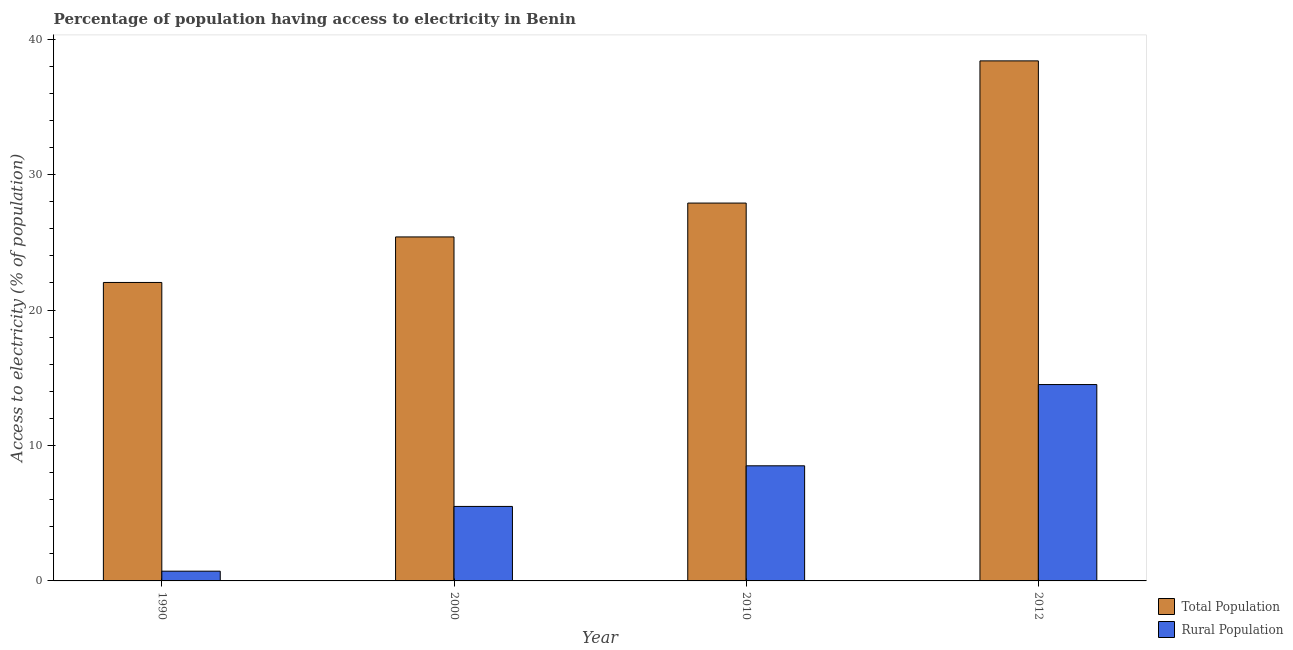How many different coloured bars are there?
Provide a short and direct response. 2. How many groups of bars are there?
Your response must be concise. 4. Are the number of bars per tick equal to the number of legend labels?
Provide a short and direct response. Yes. How many bars are there on the 1st tick from the left?
Offer a terse response. 2. How many bars are there on the 2nd tick from the right?
Ensure brevity in your answer.  2. Across all years, what is the maximum percentage of rural population having access to electricity?
Offer a terse response. 14.5. Across all years, what is the minimum percentage of rural population having access to electricity?
Offer a terse response. 0.72. In which year was the percentage of rural population having access to electricity maximum?
Offer a very short reply. 2012. What is the total percentage of population having access to electricity in the graph?
Offer a terse response. 113.74. What is the difference between the percentage of population having access to electricity in 1990 and that in 2010?
Offer a terse response. -5.86. What is the average percentage of rural population having access to electricity per year?
Your answer should be compact. 7.3. What is the ratio of the percentage of population having access to electricity in 1990 to that in 2000?
Provide a succinct answer. 0.87. What is the difference between the highest and the second highest percentage of rural population having access to electricity?
Provide a short and direct response. 6. What is the difference between the highest and the lowest percentage of population having access to electricity?
Your response must be concise. 16.36. Is the sum of the percentage of rural population having access to electricity in 2000 and 2012 greater than the maximum percentage of population having access to electricity across all years?
Your response must be concise. Yes. What does the 1st bar from the left in 2010 represents?
Your answer should be very brief. Total Population. What does the 1st bar from the right in 2000 represents?
Your answer should be compact. Rural Population. Are all the bars in the graph horizontal?
Your response must be concise. No. How many years are there in the graph?
Your response must be concise. 4. Are the values on the major ticks of Y-axis written in scientific E-notation?
Provide a short and direct response. No. Does the graph contain any zero values?
Make the answer very short. No. Does the graph contain grids?
Offer a terse response. No. Where does the legend appear in the graph?
Your response must be concise. Bottom right. What is the title of the graph?
Provide a short and direct response. Percentage of population having access to electricity in Benin. Does "Arms imports" appear as one of the legend labels in the graph?
Give a very brief answer. No. What is the label or title of the X-axis?
Give a very brief answer. Year. What is the label or title of the Y-axis?
Your answer should be very brief. Access to electricity (% of population). What is the Access to electricity (% of population) of Total Population in 1990?
Ensure brevity in your answer.  22.04. What is the Access to electricity (% of population) in Rural Population in 1990?
Ensure brevity in your answer.  0.72. What is the Access to electricity (% of population) in Total Population in 2000?
Provide a succinct answer. 25.4. What is the Access to electricity (% of population) of Total Population in 2010?
Give a very brief answer. 27.9. What is the Access to electricity (% of population) of Total Population in 2012?
Provide a succinct answer. 38.4. What is the Access to electricity (% of population) in Rural Population in 2012?
Ensure brevity in your answer.  14.5. Across all years, what is the maximum Access to electricity (% of population) in Total Population?
Make the answer very short. 38.4. Across all years, what is the minimum Access to electricity (% of population) in Total Population?
Provide a short and direct response. 22.04. Across all years, what is the minimum Access to electricity (% of population) of Rural Population?
Provide a succinct answer. 0.72. What is the total Access to electricity (% of population) of Total Population in the graph?
Give a very brief answer. 113.74. What is the total Access to electricity (% of population) of Rural Population in the graph?
Offer a terse response. 29.22. What is the difference between the Access to electricity (% of population) of Total Population in 1990 and that in 2000?
Make the answer very short. -3.36. What is the difference between the Access to electricity (% of population) in Rural Population in 1990 and that in 2000?
Provide a succinct answer. -4.78. What is the difference between the Access to electricity (% of population) of Total Population in 1990 and that in 2010?
Keep it short and to the point. -5.86. What is the difference between the Access to electricity (% of population) in Rural Population in 1990 and that in 2010?
Offer a terse response. -7.78. What is the difference between the Access to electricity (% of population) in Total Population in 1990 and that in 2012?
Provide a short and direct response. -16.36. What is the difference between the Access to electricity (% of population) of Rural Population in 1990 and that in 2012?
Give a very brief answer. -13.78. What is the difference between the Access to electricity (% of population) in Rural Population in 2000 and that in 2010?
Make the answer very short. -3. What is the difference between the Access to electricity (% of population) in Rural Population in 2000 and that in 2012?
Your response must be concise. -9. What is the difference between the Access to electricity (% of population) in Total Population in 2010 and that in 2012?
Give a very brief answer. -10.5. What is the difference between the Access to electricity (% of population) in Total Population in 1990 and the Access to electricity (% of population) in Rural Population in 2000?
Your response must be concise. 16.54. What is the difference between the Access to electricity (% of population) of Total Population in 1990 and the Access to electricity (% of population) of Rural Population in 2010?
Provide a short and direct response. 13.54. What is the difference between the Access to electricity (% of population) of Total Population in 1990 and the Access to electricity (% of population) of Rural Population in 2012?
Offer a terse response. 7.54. What is the difference between the Access to electricity (% of population) in Total Population in 2000 and the Access to electricity (% of population) in Rural Population in 2010?
Ensure brevity in your answer.  16.9. What is the difference between the Access to electricity (% of population) of Total Population in 2000 and the Access to electricity (% of population) of Rural Population in 2012?
Provide a short and direct response. 10.9. What is the average Access to electricity (% of population) in Total Population per year?
Your response must be concise. 28.43. What is the average Access to electricity (% of population) of Rural Population per year?
Your response must be concise. 7.3. In the year 1990, what is the difference between the Access to electricity (% of population) in Total Population and Access to electricity (% of population) in Rural Population?
Your answer should be very brief. 21.32. In the year 2012, what is the difference between the Access to electricity (% of population) in Total Population and Access to electricity (% of population) in Rural Population?
Provide a short and direct response. 23.9. What is the ratio of the Access to electricity (% of population) in Total Population in 1990 to that in 2000?
Keep it short and to the point. 0.87. What is the ratio of the Access to electricity (% of population) of Rural Population in 1990 to that in 2000?
Offer a very short reply. 0.13. What is the ratio of the Access to electricity (% of population) of Total Population in 1990 to that in 2010?
Make the answer very short. 0.79. What is the ratio of the Access to electricity (% of population) of Rural Population in 1990 to that in 2010?
Provide a short and direct response. 0.08. What is the ratio of the Access to electricity (% of population) in Total Population in 1990 to that in 2012?
Give a very brief answer. 0.57. What is the ratio of the Access to electricity (% of population) of Rural Population in 1990 to that in 2012?
Provide a succinct answer. 0.05. What is the ratio of the Access to electricity (% of population) in Total Population in 2000 to that in 2010?
Offer a very short reply. 0.91. What is the ratio of the Access to electricity (% of population) of Rural Population in 2000 to that in 2010?
Provide a short and direct response. 0.65. What is the ratio of the Access to electricity (% of population) of Total Population in 2000 to that in 2012?
Provide a succinct answer. 0.66. What is the ratio of the Access to electricity (% of population) of Rural Population in 2000 to that in 2012?
Ensure brevity in your answer.  0.38. What is the ratio of the Access to electricity (% of population) in Total Population in 2010 to that in 2012?
Your answer should be very brief. 0.73. What is the ratio of the Access to electricity (% of population) in Rural Population in 2010 to that in 2012?
Your response must be concise. 0.59. What is the difference between the highest and the lowest Access to electricity (% of population) of Total Population?
Ensure brevity in your answer.  16.36. What is the difference between the highest and the lowest Access to electricity (% of population) in Rural Population?
Provide a succinct answer. 13.78. 